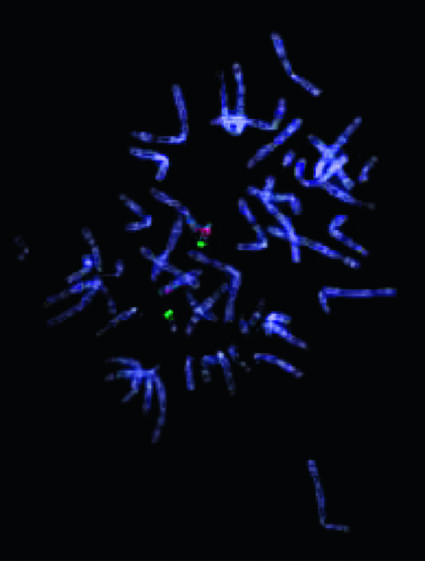what gives rise to the 22q11 .2 deletion syndrome (digeorge syndrome)?
Answer the question using a single word or phrase. This abnormality 